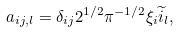<formula> <loc_0><loc_0><loc_500><loc_500>a _ { i j , l } = \delta _ { i j } 2 ^ { 1 / 2 } \pi ^ { - 1 / 2 } \xi _ { i } \widetilde { i } _ { l } ,</formula> 